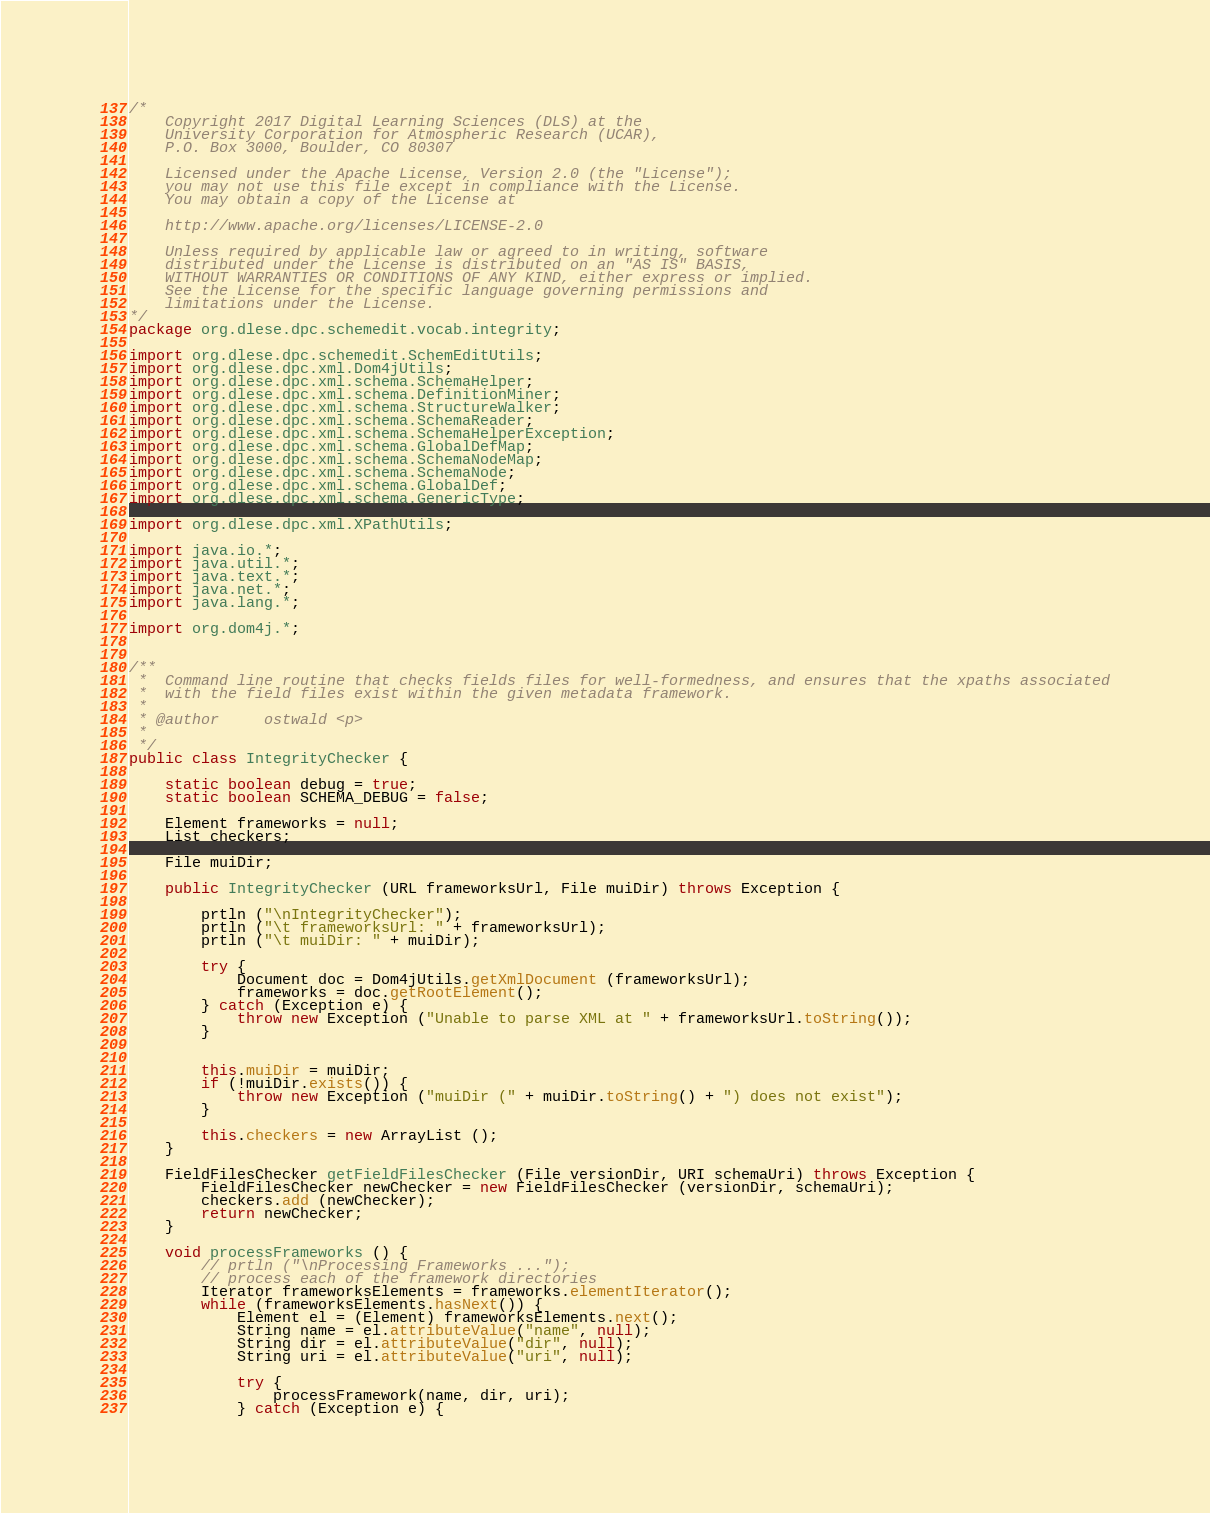Convert code to text. <code><loc_0><loc_0><loc_500><loc_500><_Java_>/*
	Copyright 2017 Digital Learning Sciences (DLS) at the
	University Corporation for Atmospheric Research (UCAR),
	P.O. Box 3000, Boulder, CO 80307

	Licensed under the Apache License, Version 2.0 (the "License");
	you may not use this file except in compliance with the License.
	You may obtain a copy of the License at

	http://www.apache.org/licenses/LICENSE-2.0

	Unless required by applicable law or agreed to in writing, software
	distributed under the License is distributed on an "AS IS" BASIS,
	WITHOUT WARRANTIES OR CONDITIONS OF ANY KIND, either express or implied.
	See the License for the specific language governing permissions and
	limitations under the License.
*/
package org.dlese.dpc.schemedit.vocab.integrity;

import org.dlese.dpc.schemedit.SchemEditUtils;
import org.dlese.dpc.xml.Dom4jUtils;
import org.dlese.dpc.xml.schema.SchemaHelper;
import org.dlese.dpc.xml.schema.DefinitionMiner;
import org.dlese.dpc.xml.schema.StructureWalker;
import org.dlese.dpc.xml.schema.SchemaReader;
import org.dlese.dpc.xml.schema.SchemaHelperException;
import org.dlese.dpc.xml.schema.GlobalDefMap;
import org.dlese.dpc.xml.schema.SchemaNodeMap;
import org.dlese.dpc.xml.schema.SchemaNode;
import org.dlese.dpc.xml.schema.GlobalDef;
import org.dlese.dpc.xml.schema.GenericType;

import org.dlese.dpc.xml.XPathUtils;

import java.io.*;
import java.util.*;
import java.text.*;
import java.net.*;
import java.lang.*;

import org.dom4j.*;


/**
 *  Command line routine that checks fields files for well-formedness, and ensures that the xpaths associated
 *  with the field files exist within the given metadata framework.
 *
 * @author     ostwald <p>
 *
 */
public class IntegrityChecker {

	static boolean debug = true;
	static boolean SCHEMA_DEBUG = false;
	
	Element frameworks = null;
	List checkers;
	
	File muiDir;
	
	public IntegrityChecker (URL frameworksUrl, File muiDir) throws Exception {
		
		prtln ("\nIntegrityChecker");
		prtln ("\t frameworksUrl: " + frameworksUrl);
		prtln ("\t muiDir: " + muiDir);
		
		try {
			Document doc = Dom4jUtils.getXmlDocument (frameworksUrl);
			frameworks = doc.getRootElement();
		} catch (Exception e) {
			throw new Exception ("Unable to parse XML at " + frameworksUrl.toString());
		}
		
		
		this.muiDir = muiDir;
		if (!muiDir.exists()) {
			throw new Exception ("muiDir (" + muiDir.toString() + ") does not exist");
		}
		
		this.checkers = new ArrayList ();
	}

	FieldFilesChecker getFieldFilesChecker (File versionDir, URI schemaUri) throws Exception {
		FieldFilesChecker newChecker = new FieldFilesChecker (versionDir, schemaUri);
		checkers.add (newChecker);
		return newChecker;
	}
	
	void processFrameworks () {
		// prtln ("\nProcessing Frameworks ...");
		// process each of the framework directories
		Iterator frameworksElements = frameworks.elementIterator();
		while (frameworksElements.hasNext()) {
			Element el = (Element) frameworksElements.next();
			String name = el.attributeValue("name", null);
			String dir = el.attributeValue("dir", null);
			String uri = el.attributeValue("uri", null);

			try {
				processFramework(name, dir, uri);
			} catch (Exception e) {</code> 